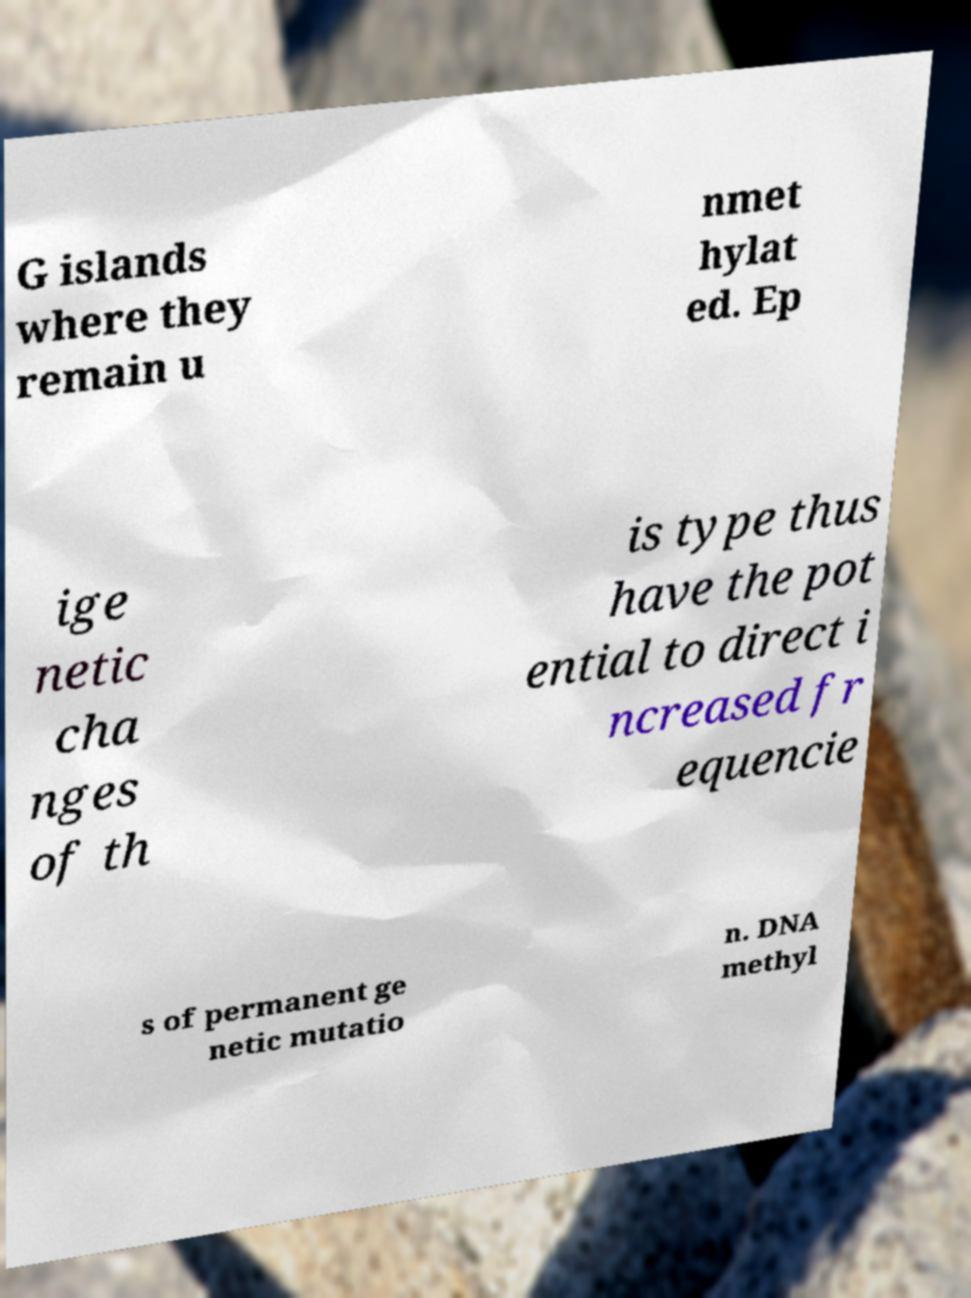What messages or text are displayed in this image? I need them in a readable, typed format. G islands where they remain u nmet hylat ed. Ep ige netic cha nges of th is type thus have the pot ential to direct i ncreased fr equencie s of permanent ge netic mutatio n. DNA methyl 